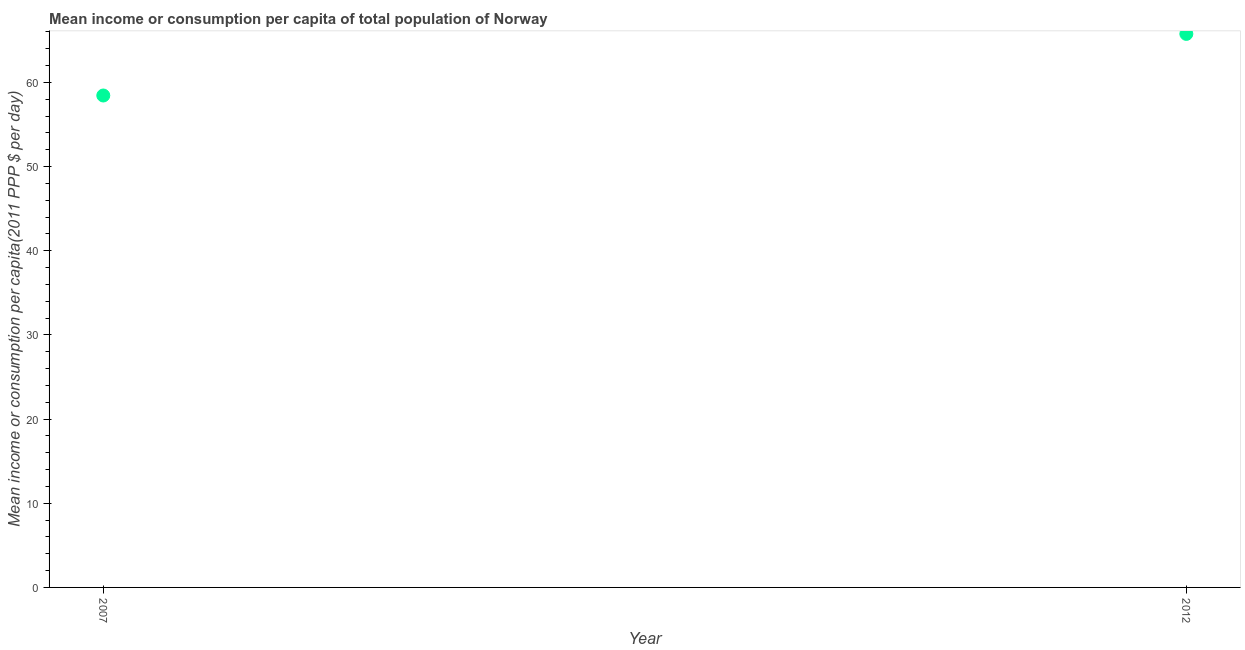What is the mean income or consumption in 2012?
Your response must be concise. 65.77. Across all years, what is the maximum mean income or consumption?
Give a very brief answer. 65.77. Across all years, what is the minimum mean income or consumption?
Offer a terse response. 58.45. In which year was the mean income or consumption minimum?
Give a very brief answer. 2007. What is the sum of the mean income or consumption?
Ensure brevity in your answer.  124.22. What is the difference between the mean income or consumption in 2007 and 2012?
Your answer should be very brief. -7.32. What is the average mean income or consumption per year?
Offer a terse response. 62.11. What is the median mean income or consumption?
Ensure brevity in your answer.  62.11. Do a majority of the years between 2007 and 2012 (inclusive) have mean income or consumption greater than 32 $?
Ensure brevity in your answer.  Yes. What is the ratio of the mean income or consumption in 2007 to that in 2012?
Offer a very short reply. 0.89. Is the mean income or consumption in 2007 less than that in 2012?
Provide a short and direct response. Yes. Does the mean income or consumption monotonically increase over the years?
Offer a terse response. Yes. How many dotlines are there?
Provide a short and direct response. 1. What is the title of the graph?
Make the answer very short. Mean income or consumption per capita of total population of Norway. What is the label or title of the X-axis?
Your answer should be very brief. Year. What is the label or title of the Y-axis?
Offer a terse response. Mean income or consumption per capita(2011 PPP $ per day). What is the Mean income or consumption per capita(2011 PPP $ per day) in 2007?
Provide a short and direct response. 58.45. What is the Mean income or consumption per capita(2011 PPP $ per day) in 2012?
Your response must be concise. 65.77. What is the difference between the Mean income or consumption per capita(2011 PPP $ per day) in 2007 and 2012?
Make the answer very short. -7.32. What is the ratio of the Mean income or consumption per capita(2011 PPP $ per day) in 2007 to that in 2012?
Give a very brief answer. 0.89. 